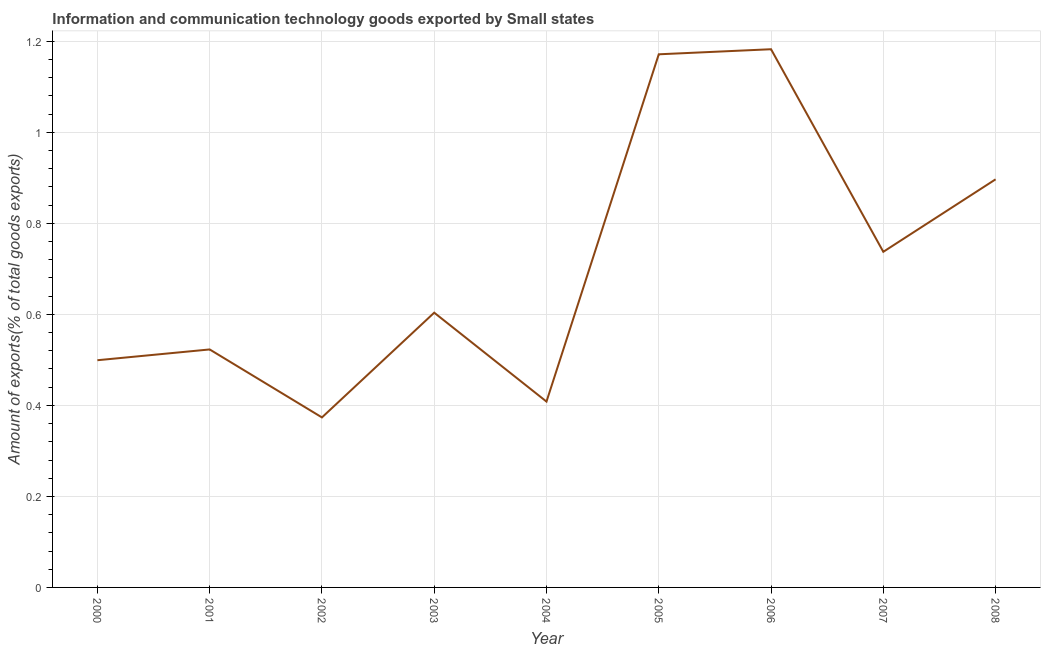What is the amount of ict goods exports in 2005?
Keep it short and to the point. 1.17. Across all years, what is the maximum amount of ict goods exports?
Make the answer very short. 1.18. Across all years, what is the minimum amount of ict goods exports?
Ensure brevity in your answer.  0.37. What is the sum of the amount of ict goods exports?
Provide a short and direct response. 6.4. What is the difference between the amount of ict goods exports in 2002 and 2005?
Ensure brevity in your answer.  -0.8. What is the average amount of ict goods exports per year?
Offer a very short reply. 0.71. What is the median amount of ict goods exports?
Provide a succinct answer. 0.6. In how many years, is the amount of ict goods exports greater than 0.12 %?
Your answer should be compact. 9. Do a majority of the years between 2004 and 2002 (inclusive) have amount of ict goods exports greater than 0.56 %?
Your response must be concise. No. What is the ratio of the amount of ict goods exports in 2000 to that in 2003?
Provide a short and direct response. 0.83. What is the difference between the highest and the second highest amount of ict goods exports?
Make the answer very short. 0.01. What is the difference between the highest and the lowest amount of ict goods exports?
Offer a very short reply. 0.81. In how many years, is the amount of ict goods exports greater than the average amount of ict goods exports taken over all years?
Your answer should be very brief. 4. Does the amount of ict goods exports monotonically increase over the years?
Your answer should be very brief. No. How many years are there in the graph?
Your answer should be compact. 9. What is the difference between two consecutive major ticks on the Y-axis?
Ensure brevity in your answer.  0.2. Are the values on the major ticks of Y-axis written in scientific E-notation?
Offer a very short reply. No. What is the title of the graph?
Make the answer very short. Information and communication technology goods exported by Small states. What is the label or title of the X-axis?
Your answer should be compact. Year. What is the label or title of the Y-axis?
Keep it short and to the point. Amount of exports(% of total goods exports). What is the Amount of exports(% of total goods exports) of 2000?
Your answer should be very brief. 0.5. What is the Amount of exports(% of total goods exports) in 2001?
Keep it short and to the point. 0.52. What is the Amount of exports(% of total goods exports) of 2002?
Offer a terse response. 0.37. What is the Amount of exports(% of total goods exports) in 2003?
Your answer should be very brief. 0.6. What is the Amount of exports(% of total goods exports) of 2004?
Your answer should be very brief. 0.41. What is the Amount of exports(% of total goods exports) of 2005?
Make the answer very short. 1.17. What is the Amount of exports(% of total goods exports) in 2006?
Ensure brevity in your answer.  1.18. What is the Amount of exports(% of total goods exports) in 2007?
Keep it short and to the point. 0.74. What is the Amount of exports(% of total goods exports) of 2008?
Keep it short and to the point. 0.9. What is the difference between the Amount of exports(% of total goods exports) in 2000 and 2001?
Keep it short and to the point. -0.02. What is the difference between the Amount of exports(% of total goods exports) in 2000 and 2002?
Offer a very short reply. 0.13. What is the difference between the Amount of exports(% of total goods exports) in 2000 and 2003?
Keep it short and to the point. -0.1. What is the difference between the Amount of exports(% of total goods exports) in 2000 and 2004?
Your response must be concise. 0.09. What is the difference between the Amount of exports(% of total goods exports) in 2000 and 2005?
Your answer should be compact. -0.67. What is the difference between the Amount of exports(% of total goods exports) in 2000 and 2006?
Keep it short and to the point. -0.68. What is the difference between the Amount of exports(% of total goods exports) in 2000 and 2007?
Provide a short and direct response. -0.24. What is the difference between the Amount of exports(% of total goods exports) in 2000 and 2008?
Give a very brief answer. -0.4. What is the difference between the Amount of exports(% of total goods exports) in 2001 and 2002?
Give a very brief answer. 0.15. What is the difference between the Amount of exports(% of total goods exports) in 2001 and 2003?
Keep it short and to the point. -0.08. What is the difference between the Amount of exports(% of total goods exports) in 2001 and 2004?
Your answer should be very brief. 0.11. What is the difference between the Amount of exports(% of total goods exports) in 2001 and 2005?
Provide a succinct answer. -0.65. What is the difference between the Amount of exports(% of total goods exports) in 2001 and 2006?
Provide a short and direct response. -0.66. What is the difference between the Amount of exports(% of total goods exports) in 2001 and 2007?
Keep it short and to the point. -0.21. What is the difference between the Amount of exports(% of total goods exports) in 2001 and 2008?
Your answer should be compact. -0.37. What is the difference between the Amount of exports(% of total goods exports) in 2002 and 2003?
Offer a terse response. -0.23. What is the difference between the Amount of exports(% of total goods exports) in 2002 and 2004?
Ensure brevity in your answer.  -0.03. What is the difference between the Amount of exports(% of total goods exports) in 2002 and 2005?
Provide a succinct answer. -0.8. What is the difference between the Amount of exports(% of total goods exports) in 2002 and 2006?
Your answer should be compact. -0.81. What is the difference between the Amount of exports(% of total goods exports) in 2002 and 2007?
Offer a terse response. -0.36. What is the difference between the Amount of exports(% of total goods exports) in 2002 and 2008?
Offer a terse response. -0.52. What is the difference between the Amount of exports(% of total goods exports) in 2003 and 2004?
Provide a short and direct response. 0.2. What is the difference between the Amount of exports(% of total goods exports) in 2003 and 2005?
Provide a short and direct response. -0.57. What is the difference between the Amount of exports(% of total goods exports) in 2003 and 2006?
Your response must be concise. -0.58. What is the difference between the Amount of exports(% of total goods exports) in 2003 and 2007?
Offer a terse response. -0.13. What is the difference between the Amount of exports(% of total goods exports) in 2003 and 2008?
Offer a very short reply. -0.29. What is the difference between the Amount of exports(% of total goods exports) in 2004 and 2005?
Provide a succinct answer. -0.76. What is the difference between the Amount of exports(% of total goods exports) in 2004 and 2006?
Your answer should be compact. -0.77. What is the difference between the Amount of exports(% of total goods exports) in 2004 and 2007?
Give a very brief answer. -0.33. What is the difference between the Amount of exports(% of total goods exports) in 2004 and 2008?
Provide a succinct answer. -0.49. What is the difference between the Amount of exports(% of total goods exports) in 2005 and 2006?
Your answer should be very brief. -0.01. What is the difference between the Amount of exports(% of total goods exports) in 2005 and 2007?
Offer a terse response. 0.43. What is the difference between the Amount of exports(% of total goods exports) in 2005 and 2008?
Provide a short and direct response. 0.27. What is the difference between the Amount of exports(% of total goods exports) in 2006 and 2007?
Keep it short and to the point. 0.45. What is the difference between the Amount of exports(% of total goods exports) in 2006 and 2008?
Keep it short and to the point. 0.29. What is the difference between the Amount of exports(% of total goods exports) in 2007 and 2008?
Your answer should be very brief. -0.16. What is the ratio of the Amount of exports(% of total goods exports) in 2000 to that in 2001?
Your answer should be very brief. 0.95. What is the ratio of the Amount of exports(% of total goods exports) in 2000 to that in 2002?
Provide a short and direct response. 1.34. What is the ratio of the Amount of exports(% of total goods exports) in 2000 to that in 2003?
Provide a succinct answer. 0.83. What is the ratio of the Amount of exports(% of total goods exports) in 2000 to that in 2004?
Ensure brevity in your answer.  1.22. What is the ratio of the Amount of exports(% of total goods exports) in 2000 to that in 2005?
Provide a succinct answer. 0.43. What is the ratio of the Amount of exports(% of total goods exports) in 2000 to that in 2006?
Make the answer very short. 0.42. What is the ratio of the Amount of exports(% of total goods exports) in 2000 to that in 2007?
Give a very brief answer. 0.68. What is the ratio of the Amount of exports(% of total goods exports) in 2000 to that in 2008?
Provide a succinct answer. 0.56. What is the ratio of the Amount of exports(% of total goods exports) in 2001 to that in 2003?
Offer a very short reply. 0.87. What is the ratio of the Amount of exports(% of total goods exports) in 2001 to that in 2004?
Offer a very short reply. 1.28. What is the ratio of the Amount of exports(% of total goods exports) in 2001 to that in 2005?
Give a very brief answer. 0.45. What is the ratio of the Amount of exports(% of total goods exports) in 2001 to that in 2006?
Your answer should be very brief. 0.44. What is the ratio of the Amount of exports(% of total goods exports) in 2001 to that in 2007?
Ensure brevity in your answer.  0.71. What is the ratio of the Amount of exports(% of total goods exports) in 2001 to that in 2008?
Offer a very short reply. 0.58. What is the ratio of the Amount of exports(% of total goods exports) in 2002 to that in 2003?
Provide a short and direct response. 0.62. What is the ratio of the Amount of exports(% of total goods exports) in 2002 to that in 2004?
Make the answer very short. 0.92. What is the ratio of the Amount of exports(% of total goods exports) in 2002 to that in 2005?
Make the answer very short. 0.32. What is the ratio of the Amount of exports(% of total goods exports) in 2002 to that in 2006?
Your response must be concise. 0.32. What is the ratio of the Amount of exports(% of total goods exports) in 2002 to that in 2007?
Provide a short and direct response. 0.51. What is the ratio of the Amount of exports(% of total goods exports) in 2002 to that in 2008?
Offer a very short reply. 0.42. What is the ratio of the Amount of exports(% of total goods exports) in 2003 to that in 2004?
Ensure brevity in your answer.  1.48. What is the ratio of the Amount of exports(% of total goods exports) in 2003 to that in 2005?
Your answer should be compact. 0.52. What is the ratio of the Amount of exports(% of total goods exports) in 2003 to that in 2006?
Offer a terse response. 0.51. What is the ratio of the Amount of exports(% of total goods exports) in 2003 to that in 2007?
Provide a short and direct response. 0.82. What is the ratio of the Amount of exports(% of total goods exports) in 2003 to that in 2008?
Provide a short and direct response. 0.67. What is the ratio of the Amount of exports(% of total goods exports) in 2004 to that in 2005?
Offer a terse response. 0.35. What is the ratio of the Amount of exports(% of total goods exports) in 2004 to that in 2006?
Offer a very short reply. 0.34. What is the ratio of the Amount of exports(% of total goods exports) in 2004 to that in 2007?
Provide a short and direct response. 0.55. What is the ratio of the Amount of exports(% of total goods exports) in 2004 to that in 2008?
Keep it short and to the point. 0.46. What is the ratio of the Amount of exports(% of total goods exports) in 2005 to that in 2007?
Your answer should be compact. 1.59. What is the ratio of the Amount of exports(% of total goods exports) in 2005 to that in 2008?
Offer a very short reply. 1.31. What is the ratio of the Amount of exports(% of total goods exports) in 2006 to that in 2007?
Your answer should be compact. 1.6. What is the ratio of the Amount of exports(% of total goods exports) in 2006 to that in 2008?
Keep it short and to the point. 1.32. What is the ratio of the Amount of exports(% of total goods exports) in 2007 to that in 2008?
Your answer should be very brief. 0.82. 